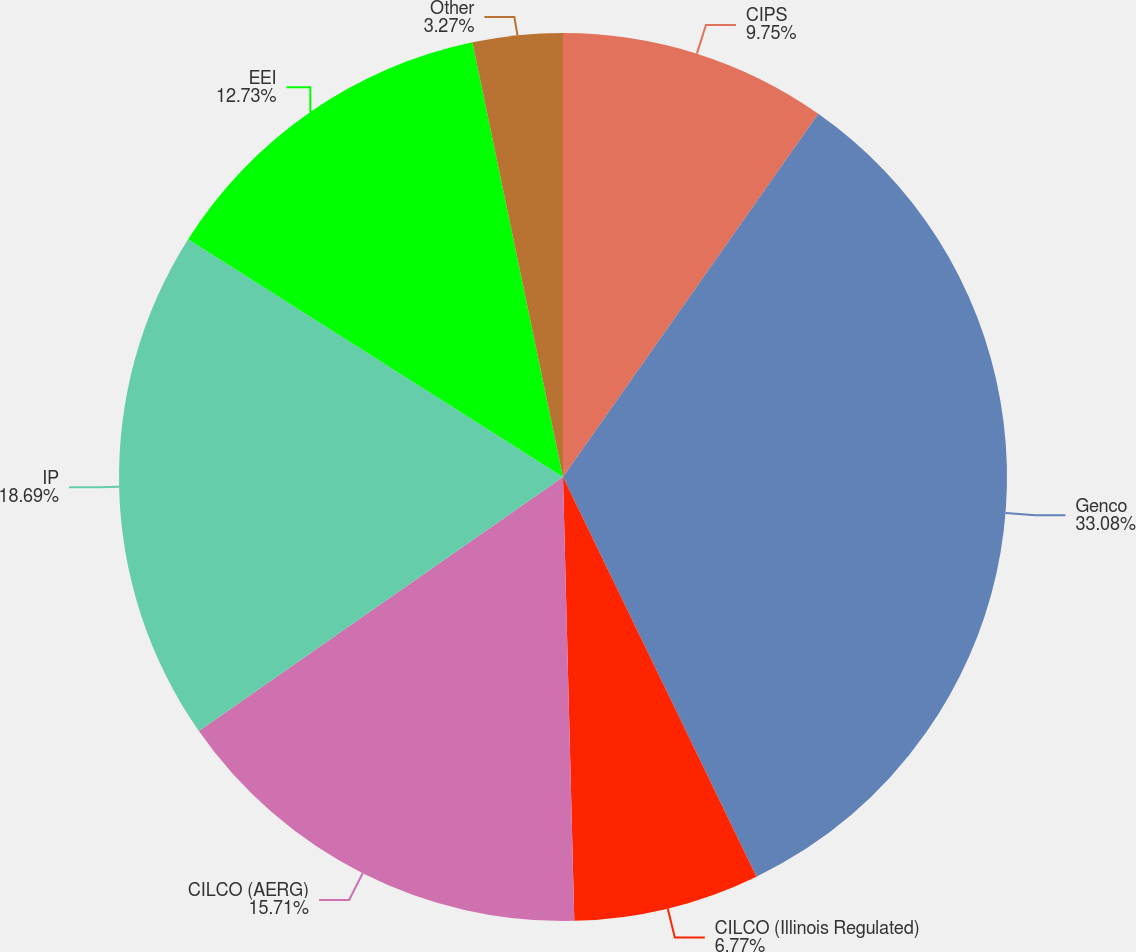<chart> <loc_0><loc_0><loc_500><loc_500><pie_chart><fcel>CIPS<fcel>Genco<fcel>CILCO (Illinois Regulated)<fcel>CILCO (AERG)<fcel>IP<fcel>EEI<fcel>Other<nl><fcel>9.75%<fcel>33.07%<fcel>6.77%<fcel>15.71%<fcel>18.69%<fcel>12.73%<fcel>3.27%<nl></chart> 